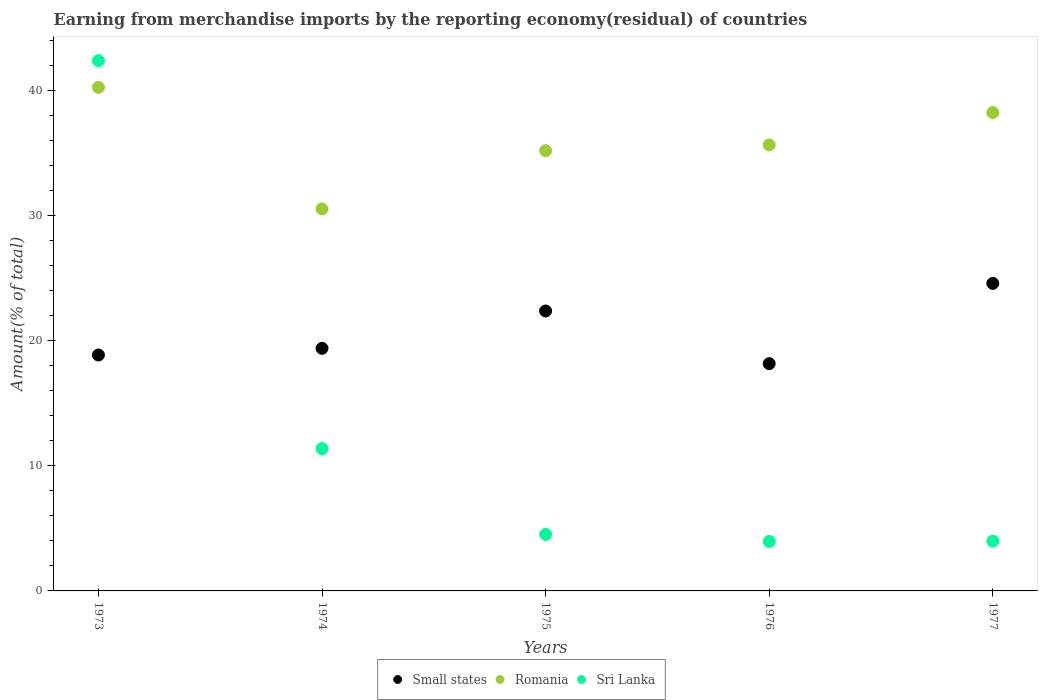How many different coloured dotlines are there?
Make the answer very short. 3. What is the percentage of amount earned from merchandise imports in Small states in 1973?
Your answer should be very brief. 18.86. Across all years, what is the maximum percentage of amount earned from merchandise imports in Sri Lanka?
Provide a succinct answer. 42.39. Across all years, what is the minimum percentage of amount earned from merchandise imports in Romania?
Make the answer very short. 30.54. In which year was the percentage of amount earned from merchandise imports in Small states minimum?
Keep it short and to the point. 1976. What is the total percentage of amount earned from merchandise imports in Sri Lanka in the graph?
Offer a very short reply. 66.23. What is the difference between the percentage of amount earned from merchandise imports in Sri Lanka in 1974 and that in 1975?
Make the answer very short. 6.86. What is the difference between the percentage of amount earned from merchandise imports in Small states in 1974 and the percentage of amount earned from merchandise imports in Sri Lanka in 1977?
Give a very brief answer. 15.41. What is the average percentage of amount earned from merchandise imports in Romania per year?
Provide a short and direct response. 35.97. In the year 1977, what is the difference between the percentage of amount earned from merchandise imports in Romania and percentage of amount earned from merchandise imports in Sri Lanka?
Offer a terse response. 34.26. What is the ratio of the percentage of amount earned from merchandise imports in Romania in 1973 to that in 1977?
Offer a very short reply. 1.05. Is the percentage of amount earned from merchandise imports in Small states in 1975 less than that in 1977?
Make the answer very short. Yes. Is the difference between the percentage of amount earned from merchandise imports in Romania in 1973 and 1977 greater than the difference between the percentage of amount earned from merchandise imports in Sri Lanka in 1973 and 1977?
Provide a succinct answer. No. What is the difference between the highest and the second highest percentage of amount earned from merchandise imports in Sri Lanka?
Provide a succinct answer. 31.01. What is the difference between the highest and the lowest percentage of amount earned from merchandise imports in Sri Lanka?
Your response must be concise. 38.43. Is the sum of the percentage of amount earned from merchandise imports in Small states in 1975 and 1976 greater than the maximum percentage of amount earned from merchandise imports in Romania across all years?
Give a very brief answer. Yes. Is it the case that in every year, the sum of the percentage of amount earned from merchandise imports in Romania and percentage of amount earned from merchandise imports in Sri Lanka  is greater than the percentage of amount earned from merchandise imports in Small states?
Offer a terse response. Yes. Does the percentage of amount earned from merchandise imports in Sri Lanka monotonically increase over the years?
Ensure brevity in your answer.  No. Does the graph contain any zero values?
Make the answer very short. No. Does the graph contain grids?
Your answer should be very brief. No. Where does the legend appear in the graph?
Your response must be concise. Bottom center. What is the title of the graph?
Offer a very short reply. Earning from merchandise imports by the reporting economy(residual) of countries. Does "Egypt, Arab Rep." appear as one of the legend labels in the graph?
Make the answer very short. No. What is the label or title of the X-axis?
Offer a terse response. Years. What is the label or title of the Y-axis?
Your answer should be compact. Amount(% of total). What is the Amount(% of total) of Small states in 1973?
Make the answer very short. 18.86. What is the Amount(% of total) in Romania in 1973?
Offer a terse response. 40.25. What is the Amount(% of total) of Sri Lanka in 1973?
Your answer should be compact. 42.39. What is the Amount(% of total) of Small states in 1974?
Give a very brief answer. 19.39. What is the Amount(% of total) of Romania in 1974?
Your answer should be very brief. 30.54. What is the Amount(% of total) of Sri Lanka in 1974?
Keep it short and to the point. 11.38. What is the Amount(% of total) of Small states in 1975?
Ensure brevity in your answer.  22.37. What is the Amount(% of total) of Romania in 1975?
Give a very brief answer. 35.19. What is the Amount(% of total) of Sri Lanka in 1975?
Offer a very short reply. 4.52. What is the Amount(% of total) of Small states in 1976?
Provide a succinct answer. 18.16. What is the Amount(% of total) of Romania in 1976?
Ensure brevity in your answer.  35.65. What is the Amount(% of total) of Sri Lanka in 1976?
Offer a very short reply. 3.96. What is the Amount(% of total) of Small states in 1977?
Ensure brevity in your answer.  24.58. What is the Amount(% of total) of Romania in 1977?
Offer a very short reply. 38.24. What is the Amount(% of total) in Sri Lanka in 1977?
Offer a terse response. 3.98. Across all years, what is the maximum Amount(% of total) of Small states?
Your answer should be compact. 24.58. Across all years, what is the maximum Amount(% of total) of Romania?
Your answer should be compact. 40.25. Across all years, what is the maximum Amount(% of total) of Sri Lanka?
Your answer should be very brief. 42.39. Across all years, what is the minimum Amount(% of total) in Small states?
Keep it short and to the point. 18.16. Across all years, what is the minimum Amount(% of total) of Romania?
Offer a very short reply. 30.54. Across all years, what is the minimum Amount(% of total) of Sri Lanka?
Keep it short and to the point. 3.96. What is the total Amount(% of total) in Small states in the graph?
Your response must be concise. 103.36. What is the total Amount(% of total) of Romania in the graph?
Make the answer very short. 179.86. What is the total Amount(% of total) in Sri Lanka in the graph?
Offer a terse response. 66.23. What is the difference between the Amount(% of total) of Small states in 1973 and that in 1974?
Your response must be concise. -0.53. What is the difference between the Amount(% of total) of Romania in 1973 and that in 1974?
Offer a very short reply. 9.71. What is the difference between the Amount(% of total) of Sri Lanka in 1973 and that in 1974?
Keep it short and to the point. 31.01. What is the difference between the Amount(% of total) of Small states in 1973 and that in 1975?
Your answer should be compact. -3.52. What is the difference between the Amount(% of total) of Romania in 1973 and that in 1975?
Give a very brief answer. 5.06. What is the difference between the Amount(% of total) in Sri Lanka in 1973 and that in 1975?
Give a very brief answer. 37.86. What is the difference between the Amount(% of total) of Small states in 1973 and that in 1976?
Offer a very short reply. 0.69. What is the difference between the Amount(% of total) of Romania in 1973 and that in 1976?
Your answer should be very brief. 4.6. What is the difference between the Amount(% of total) in Sri Lanka in 1973 and that in 1976?
Provide a short and direct response. 38.43. What is the difference between the Amount(% of total) in Small states in 1973 and that in 1977?
Your response must be concise. -5.72. What is the difference between the Amount(% of total) of Romania in 1973 and that in 1977?
Offer a very short reply. 2.01. What is the difference between the Amount(% of total) of Sri Lanka in 1973 and that in 1977?
Make the answer very short. 38.4. What is the difference between the Amount(% of total) in Small states in 1974 and that in 1975?
Your response must be concise. -2.99. What is the difference between the Amount(% of total) in Romania in 1974 and that in 1975?
Provide a short and direct response. -4.65. What is the difference between the Amount(% of total) in Sri Lanka in 1974 and that in 1975?
Your answer should be very brief. 6.86. What is the difference between the Amount(% of total) of Small states in 1974 and that in 1976?
Keep it short and to the point. 1.22. What is the difference between the Amount(% of total) in Romania in 1974 and that in 1976?
Ensure brevity in your answer.  -5.11. What is the difference between the Amount(% of total) in Sri Lanka in 1974 and that in 1976?
Keep it short and to the point. 7.42. What is the difference between the Amount(% of total) in Small states in 1974 and that in 1977?
Make the answer very short. -5.19. What is the difference between the Amount(% of total) of Romania in 1974 and that in 1977?
Offer a terse response. -7.7. What is the difference between the Amount(% of total) of Sri Lanka in 1974 and that in 1977?
Your answer should be compact. 7.4. What is the difference between the Amount(% of total) of Small states in 1975 and that in 1976?
Keep it short and to the point. 4.21. What is the difference between the Amount(% of total) of Romania in 1975 and that in 1976?
Your response must be concise. -0.46. What is the difference between the Amount(% of total) in Sri Lanka in 1975 and that in 1976?
Provide a succinct answer. 0.56. What is the difference between the Amount(% of total) of Small states in 1975 and that in 1977?
Ensure brevity in your answer.  -2.21. What is the difference between the Amount(% of total) in Romania in 1975 and that in 1977?
Ensure brevity in your answer.  -3.05. What is the difference between the Amount(% of total) in Sri Lanka in 1975 and that in 1977?
Give a very brief answer. 0.54. What is the difference between the Amount(% of total) of Small states in 1976 and that in 1977?
Your answer should be very brief. -6.41. What is the difference between the Amount(% of total) of Romania in 1976 and that in 1977?
Offer a terse response. -2.59. What is the difference between the Amount(% of total) in Sri Lanka in 1976 and that in 1977?
Ensure brevity in your answer.  -0.02. What is the difference between the Amount(% of total) of Small states in 1973 and the Amount(% of total) of Romania in 1974?
Your response must be concise. -11.68. What is the difference between the Amount(% of total) in Small states in 1973 and the Amount(% of total) in Sri Lanka in 1974?
Provide a succinct answer. 7.48. What is the difference between the Amount(% of total) of Romania in 1973 and the Amount(% of total) of Sri Lanka in 1974?
Keep it short and to the point. 28.87. What is the difference between the Amount(% of total) in Small states in 1973 and the Amount(% of total) in Romania in 1975?
Offer a terse response. -16.33. What is the difference between the Amount(% of total) of Small states in 1973 and the Amount(% of total) of Sri Lanka in 1975?
Offer a very short reply. 14.33. What is the difference between the Amount(% of total) in Romania in 1973 and the Amount(% of total) in Sri Lanka in 1975?
Make the answer very short. 35.73. What is the difference between the Amount(% of total) in Small states in 1973 and the Amount(% of total) in Romania in 1976?
Ensure brevity in your answer.  -16.79. What is the difference between the Amount(% of total) in Small states in 1973 and the Amount(% of total) in Sri Lanka in 1976?
Provide a succinct answer. 14.9. What is the difference between the Amount(% of total) in Romania in 1973 and the Amount(% of total) in Sri Lanka in 1976?
Provide a short and direct response. 36.29. What is the difference between the Amount(% of total) in Small states in 1973 and the Amount(% of total) in Romania in 1977?
Keep it short and to the point. -19.38. What is the difference between the Amount(% of total) in Small states in 1973 and the Amount(% of total) in Sri Lanka in 1977?
Keep it short and to the point. 14.87. What is the difference between the Amount(% of total) of Romania in 1973 and the Amount(% of total) of Sri Lanka in 1977?
Your response must be concise. 36.27. What is the difference between the Amount(% of total) of Small states in 1974 and the Amount(% of total) of Romania in 1975?
Your response must be concise. -15.8. What is the difference between the Amount(% of total) in Small states in 1974 and the Amount(% of total) in Sri Lanka in 1975?
Make the answer very short. 14.87. What is the difference between the Amount(% of total) in Romania in 1974 and the Amount(% of total) in Sri Lanka in 1975?
Provide a succinct answer. 26.01. What is the difference between the Amount(% of total) in Small states in 1974 and the Amount(% of total) in Romania in 1976?
Offer a very short reply. -16.26. What is the difference between the Amount(% of total) in Small states in 1974 and the Amount(% of total) in Sri Lanka in 1976?
Your response must be concise. 15.43. What is the difference between the Amount(% of total) in Romania in 1974 and the Amount(% of total) in Sri Lanka in 1976?
Ensure brevity in your answer.  26.58. What is the difference between the Amount(% of total) of Small states in 1974 and the Amount(% of total) of Romania in 1977?
Keep it short and to the point. -18.85. What is the difference between the Amount(% of total) of Small states in 1974 and the Amount(% of total) of Sri Lanka in 1977?
Your response must be concise. 15.41. What is the difference between the Amount(% of total) of Romania in 1974 and the Amount(% of total) of Sri Lanka in 1977?
Your response must be concise. 26.55. What is the difference between the Amount(% of total) of Small states in 1975 and the Amount(% of total) of Romania in 1976?
Your answer should be compact. -13.28. What is the difference between the Amount(% of total) of Small states in 1975 and the Amount(% of total) of Sri Lanka in 1976?
Give a very brief answer. 18.42. What is the difference between the Amount(% of total) in Romania in 1975 and the Amount(% of total) in Sri Lanka in 1976?
Give a very brief answer. 31.23. What is the difference between the Amount(% of total) in Small states in 1975 and the Amount(% of total) in Romania in 1977?
Your answer should be very brief. -15.86. What is the difference between the Amount(% of total) in Small states in 1975 and the Amount(% of total) in Sri Lanka in 1977?
Your answer should be compact. 18.39. What is the difference between the Amount(% of total) of Romania in 1975 and the Amount(% of total) of Sri Lanka in 1977?
Offer a very short reply. 31.21. What is the difference between the Amount(% of total) of Small states in 1976 and the Amount(% of total) of Romania in 1977?
Keep it short and to the point. -20.07. What is the difference between the Amount(% of total) in Small states in 1976 and the Amount(% of total) in Sri Lanka in 1977?
Keep it short and to the point. 14.18. What is the difference between the Amount(% of total) in Romania in 1976 and the Amount(% of total) in Sri Lanka in 1977?
Provide a succinct answer. 31.67. What is the average Amount(% of total) in Small states per year?
Offer a terse response. 20.67. What is the average Amount(% of total) in Romania per year?
Give a very brief answer. 35.97. What is the average Amount(% of total) of Sri Lanka per year?
Offer a very short reply. 13.25. In the year 1973, what is the difference between the Amount(% of total) in Small states and Amount(% of total) in Romania?
Your answer should be compact. -21.39. In the year 1973, what is the difference between the Amount(% of total) in Small states and Amount(% of total) in Sri Lanka?
Provide a short and direct response. -23.53. In the year 1973, what is the difference between the Amount(% of total) in Romania and Amount(% of total) in Sri Lanka?
Give a very brief answer. -2.14. In the year 1974, what is the difference between the Amount(% of total) in Small states and Amount(% of total) in Romania?
Your answer should be compact. -11.15. In the year 1974, what is the difference between the Amount(% of total) in Small states and Amount(% of total) in Sri Lanka?
Ensure brevity in your answer.  8.01. In the year 1974, what is the difference between the Amount(% of total) of Romania and Amount(% of total) of Sri Lanka?
Ensure brevity in your answer.  19.16. In the year 1975, what is the difference between the Amount(% of total) of Small states and Amount(% of total) of Romania?
Provide a succinct answer. -12.81. In the year 1975, what is the difference between the Amount(% of total) in Small states and Amount(% of total) in Sri Lanka?
Offer a terse response. 17.85. In the year 1975, what is the difference between the Amount(% of total) of Romania and Amount(% of total) of Sri Lanka?
Give a very brief answer. 30.67. In the year 1976, what is the difference between the Amount(% of total) of Small states and Amount(% of total) of Romania?
Provide a short and direct response. -17.48. In the year 1976, what is the difference between the Amount(% of total) of Small states and Amount(% of total) of Sri Lanka?
Ensure brevity in your answer.  14.21. In the year 1976, what is the difference between the Amount(% of total) of Romania and Amount(% of total) of Sri Lanka?
Make the answer very short. 31.69. In the year 1977, what is the difference between the Amount(% of total) of Small states and Amount(% of total) of Romania?
Provide a succinct answer. -13.66. In the year 1977, what is the difference between the Amount(% of total) in Small states and Amount(% of total) in Sri Lanka?
Offer a terse response. 20.6. In the year 1977, what is the difference between the Amount(% of total) in Romania and Amount(% of total) in Sri Lanka?
Your answer should be compact. 34.26. What is the ratio of the Amount(% of total) of Small states in 1973 to that in 1974?
Keep it short and to the point. 0.97. What is the ratio of the Amount(% of total) in Romania in 1973 to that in 1974?
Offer a very short reply. 1.32. What is the ratio of the Amount(% of total) in Sri Lanka in 1973 to that in 1974?
Your answer should be compact. 3.73. What is the ratio of the Amount(% of total) of Small states in 1973 to that in 1975?
Ensure brevity in your answer.  0.84. What is the ratio of the Amount(% of total) of Romania in 1973 to that in 1975?
Make the answer very short. 1.14. What is the ratio of the Amount(% of total) in Sri Lanka in 1973 to that in 1975?
Ensure brevity in your answer.  9.37. What is the ratio of the Amount(% of total) of Small states in 1973 to that in 1976?
Your answer should be compact. 1.04. What is the ratio of the Amount(% of total) of Romania in 1973 to that in 1976?
Provide a short and direct response. 1.13. What is the ratio of the Amount(% of total) in Sri Lanka in 1973 to that in 1976?
Keep it short and to the point. 10.71. What is the ratio of the Amount(% of total) in Small states in 1973 to that in 1977?
Offer a terse response. 0.77. What is the ratio of the Amount(% of total) in Romania in 1973 to that in 1977?
Make the answer very short. 1.05. What is the ratio of the Amount(% of total) in Sri Lanka in 1973 to that in 1977?
Give a very brief answer. 10.64. What is the ratio of the Amount(% of total) of Small states in 1974 to that in 1975?
Offer a very short reply. 0.87. What is the ratio of the Amount(% of total) in Romania in 1974 to that in 1975?
Give a very brief answer. 0.87. What is the ratio of the Amount(% of total) of Sri Lanka in 1974 to that in 1975?
Ensure brevity in your answer.  2.52. What is the ratio of the Amount(% of total) in Small states in 1974 to that in 1976?
Make the answer very short. 1.07. What is the ratio of the Amount(% of total) of Romania in 1974 to that in 1976?
Give a very brief answer. 0.86. What is the ratio of the Amount(% of total) of Sri Lanka in 1974 to that in 1976?
Your response must be concise. 2.87. What is the ratio of the Amount(% of total) in Small states in 1974 to that in 1977?
Keep it short and to the point. 0.79. What is the ratio of the Amount(% of total) in Romania in 1974 to that in 1977?
Make the answer very short. 0.8. What is the ratio of the Amount(% of total) of Sri Lanka in 1974 to that in 1977?
Provide a succinct answer. 2.86. What is the ratio of the Amount(% of total) in Small states in 1975 to that in 1976?
Offer a very short reply. 1.23. What is the ratio of the Amount(% of total) in Sri Lanka in 1975 to that in 1976?
Make the answer very short. 1.14. What is the ratio of the Amount(% of total) in Small states in 1975 to that in 1977?
Offer a terse response. 0.91. What is the ratio of the Amount(% of total) of Romania in 1975 to that in 1977?
Offer a very short reply. 0.92. What is the ratio of the Amount(% of total) in Sri Lanka in 1975 to that in 1977?
Keep it short and to the point. 1.14. What is the ratio of the Amount(% of total) in Small states in 1976 to that in 1977?
Offer a terse response. 0.74. What is the ratio of the Amount(% of total) of Romania in 1976 to that in 1977?
Your answer should be very brief. 0.93. What is the ratio of the Amount(% of total) of Sri Lanka in 1976 to that in 1977?
Your answer should be compact. 0.99. What is the difference between the highest and the second highest Amount(% of total) in Small states?
Your response must be concise. 2.21. What is the difference between the highest and the second highest Amount(% of total) in Romania?
Your response must be concise. 2.01. What is the difference between the highest and the second highest Amount(% of total) in Sri Lanka?
Offer a very short reply. 31.01. What is the difference between the highest and the lowest Amount(% of total) in Small states?
Your answer should be compact. 6.41. What is the difference between the highest and the lowest Amount(% of total) in Romania?
Offer a very short reply. 9.71. What is the difference between the highest and the lowest Amount(% of total) of Sri Lanka?
Offer a terse response. 38.43. 